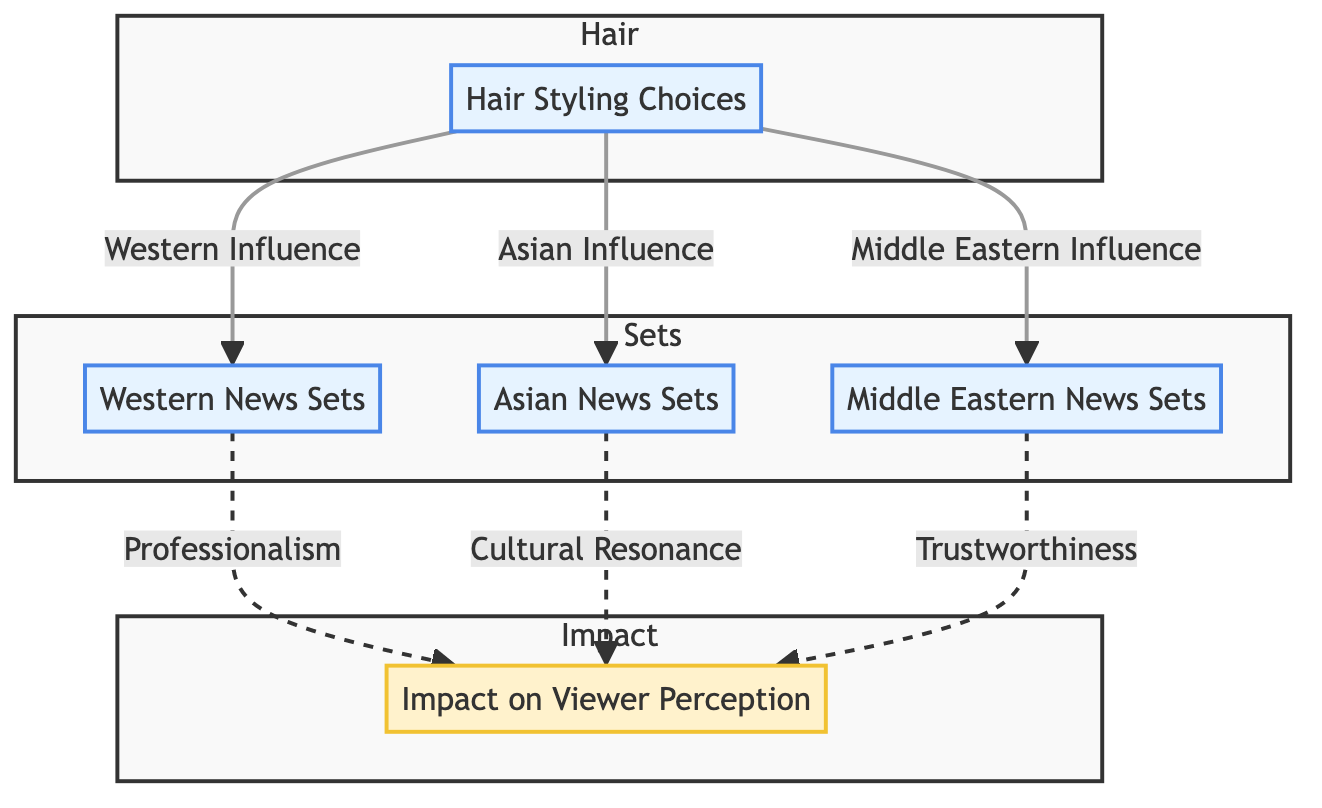What are the three cultural influences shown in the Hair Styling Choices node? The Hair Styling Choices node connects to three different set design elements: Western Influence, Asian Influence, and Middle Eastern Influence. These categories represent the cultural hair styling influences relevant to the news sets.
Answer: Western Influence, Asian Influence, Middle Eastern Influence Which set design category is linked to the notion of Professionalism? The Professionalism factor in viewer perception is linked directly to the Western News Sets according to the diagram. This indicates that the connection between hair styling and viewer perception emphasizes professionalism in Western contexts.
Answer: Western News Sets How many set design categories are represented in the diagram? There are three distinct set design categories present in the diagram: Western News Sets, Asian News Sets, and Middle Eastern News Sets. This is visible as three separate nodes connected to the Hair Styling Choices node.
Answer: 3 What impact does the Asian News Sets influence have on viewer perception? The Asian News Sets influence directly relates to the concept of Cultural Resonance in viewer perception. This means that the choices made in Asian set design resonate culturally with the audience.
Answer: Cultural Resonance Which viewer perception concept is associated with Middle Eastern News Sets? The Middle Eastern News Sets are associated with Trustworthiness as a viewer perception concept. Therefore, the diagram indicates that these set designs instill a sense of trust among viewers.
Answer: Trustworthiness How many total edges are present in the diagram? Counting the connections, there are seven edges indicated. This counts the lines linking the Hair Styling Choices to each News Set and from each News Set to the corresponding viewer perception.
Answer: 7 